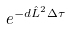Convert formula to latex. <formula><loc_0><loc_0><loc_500><loc_500>e ^ { - d \hat { L } ^ { 2 } \Delta \tau }</formula> 